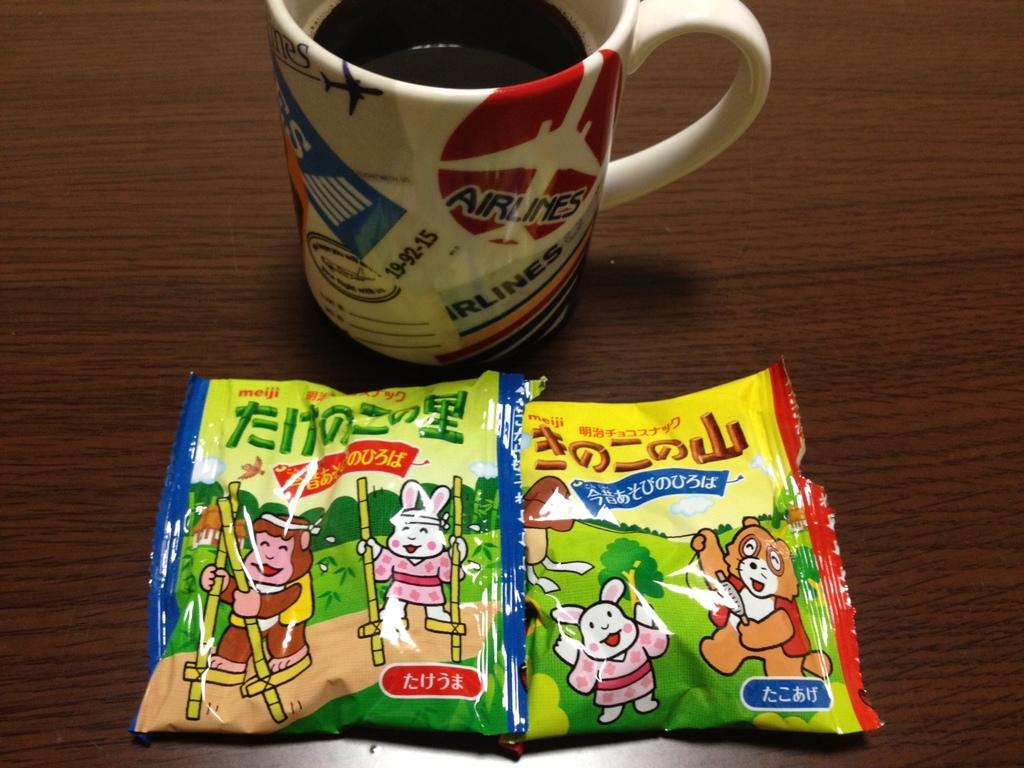What is in the cup that is visible in the image? There is a drink in the cup that is visible in the image. What else can be seen in the image besides the cup? There are two packets in the image. What type of surface is the cup and packets resting on? The wooden surface in the image resembles a table. What design does the brother have on his shirt in the image? There is no brother or shirt present in the image. 